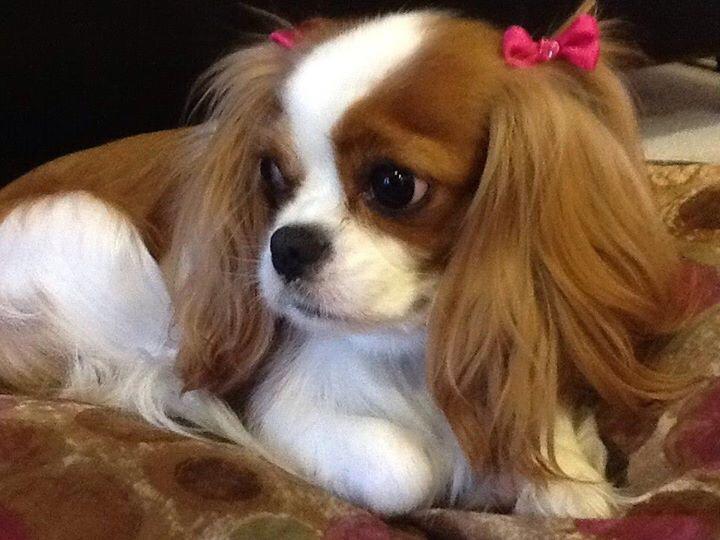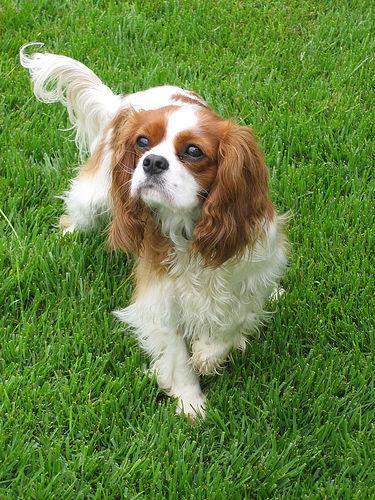The first image is the image on the left, the second image is the image on the right. Examine the images to the left and right. Is the description "Each image shows one brown and white dog on green grass." accurate? Answer yes or no. No. The first image is the image on the left, the second image is the image on the right. Assess this claim about the two images: "Two dogs on grassy ground are visible in the left image.". Correct or not? Answer yes or no. No. The first image is the image on the left, the second image is the image on the right. Assess this claim about the two images: "The dog on the right is standing in the grass.". Correct or not? Answer yes or no. Yes. 